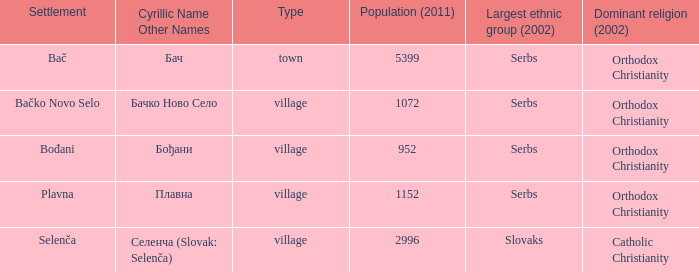How to you write  плавна with the latin alphabet? Plavna. 